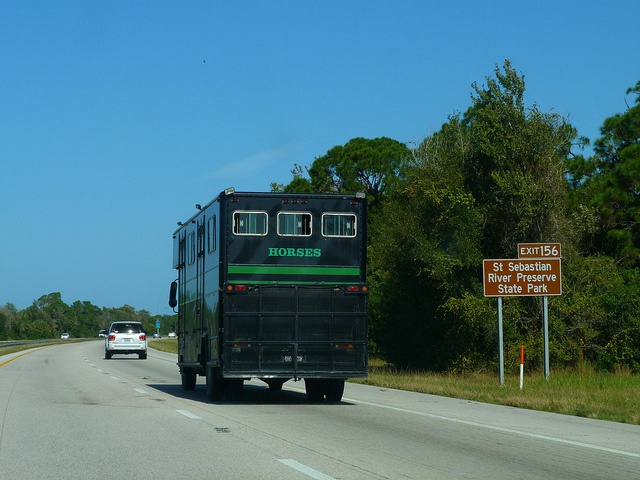Describe the objects in this image and their specific colors. I can see truck in gray, black, teal, and darkgreen tones, car in gray, black, lightgray, and darkgray tones, car in gray, darkgray, white, and black tones, car in gray, white, darkgray, and teal tones, and car in gray, purple, and black tones in this image. 